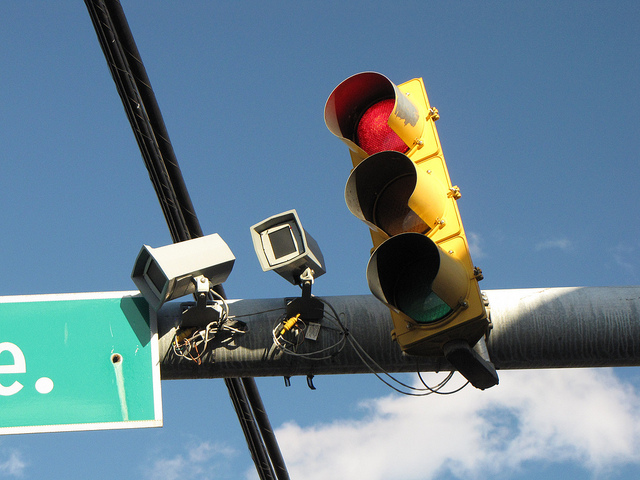Identify and read out the text in this image. e 